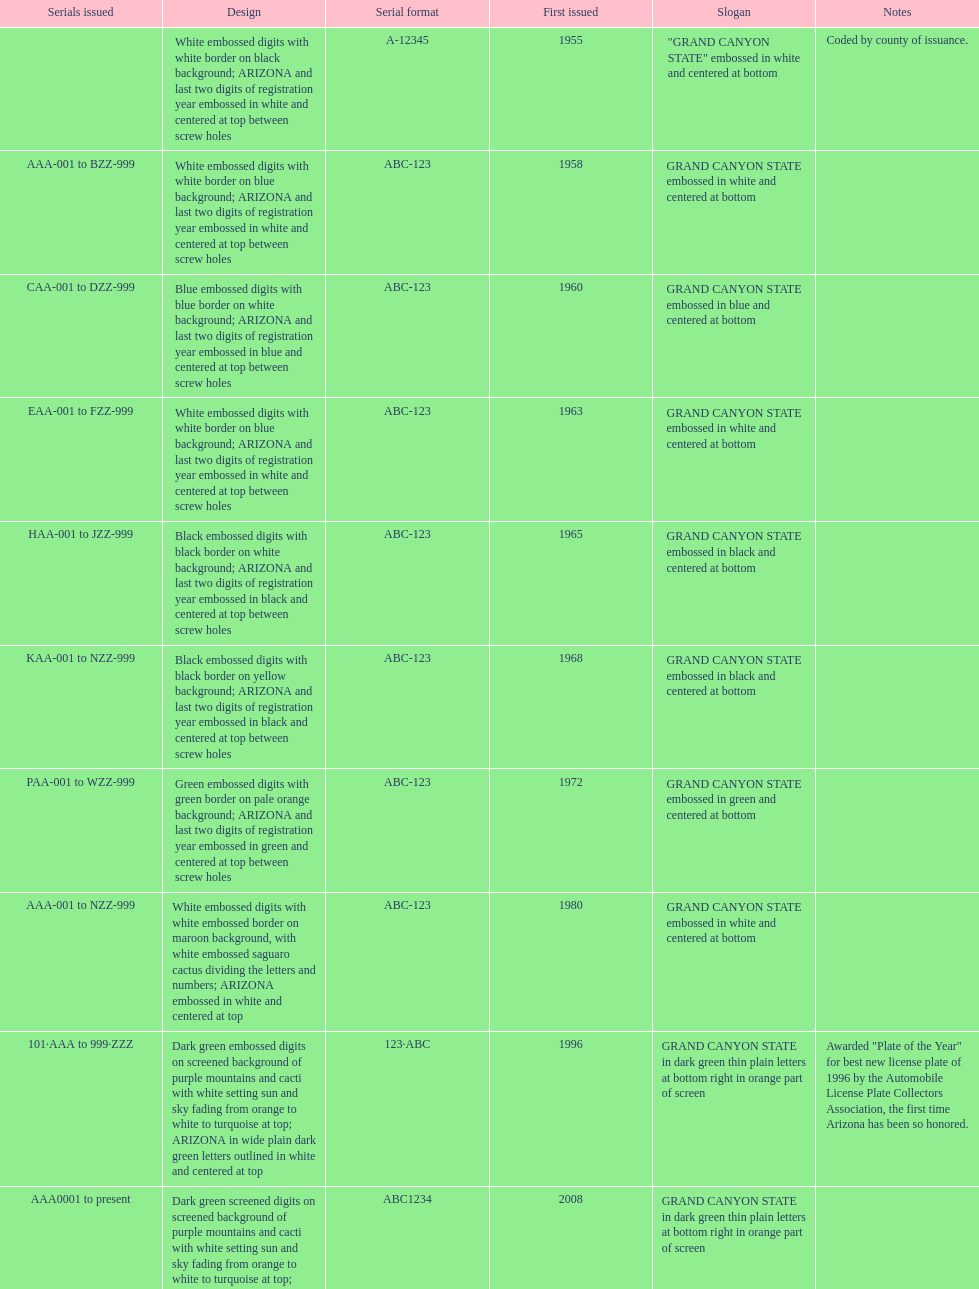Would you mind parsing the complete table? {'header': ['Serials issued', 'Design', 'Serial format', 'First issued', 'Slogan', 'Notes'], 'rows': [['', 'White embossed digits with white border on black background; ARIZONA and last two digits of registration year embossed in white and centered at top between screw holes', 'A-12345', '1955', '"GRAND CANYON STATE" embossed in white and centered at bottom', 'Coded by county of issuance.'], ['AAA-001 to BZZ-999', 'White embossed digits with white border on blue background; ARIZONA and last two digits of registration year embossed in white and centered at top between screw holes', 'ABC-123', '1958', 'GRAND CANYON STATE embossed in white and centered at bottom', ''], ['CAA-001 to DZZ-999', 'Blue embossed digits with blue border on white background; ARIZONA and last two digits of registration year embossed in blue and centered at top between screw holes', 'ABC-123', '1960', 'GRAND CANYON STATE embossed in blue and centered at bottom', ''], ['EAA-001 to FZZ-999', 'White embossed digits with white border on blue background; ARIZONA and last two digits of registration year embossed in white and centered at top between screw holes', 'ABC-123', '1963', 'GRAND CANYON STATE embossed in white and centered at bottom', ''], ['HAA-001 to JZZ-999', 'Black embossed digits with black border on white background; ARIZONA and last two digits of registration year embossed in black and centered at top between screw holes', 'ABC-123', '1965', 'GRAND CANYON STATE embossed in black and centered at bottom', ''], ['KAA-001 to NZZ-999', 'Black embossed digits with black border on yellow background; ARIZONA and last two digits of registration year embossed in black and centered at top between screw holes', 'ABC-123', '1968', 'GRAND CANYON STATE embossed in black and centered at bottom', ''], ['PAA-001 to WZZ-999', 'Green embossed digits with green border on pale orange background; ARIZONA and last two digits of registration year embossed in green and centered at top between screw holes', 'ABC-123', '1972', 'GRAND CANYON STATE embossed in green and centered at bottom', ''], ['AAA-001 to NZZ-999', 'White embossed digits with white embossed border on maroon background, with white embossed saguaro cactus dividing the letters and numbers; ARIZONA embossed in white and centered at top', 'ABC-123', '1980', 'GRAND CANYON STATE embossed in white and centered at bottom', ''], ['101·AAA to 999·ZZZ', 'Dark green embossed digits on screened background of purple mountains and cacti with white setting sun and sky fading from orange to white to turquoise at top; ARIZONA in wide plain dark green letters outlined in white and centered at top', '123·ABC', '1996', 'GRAND CANYON STATE in dark green thin plain letters at bottom right in orange part of screen', 'Awarded "Plate of the Year" for best new license plate of 1996 by the Automobile License Plate Collectors Association, the first time Arizona has been so honored.'], ['AAA0001 to present', 'Dark green screened digits on screened background of purple mountains and cacti with white setting sun and sky fading from orange to white to turquoise at top; ARIZONA in wide plain dark green letters outlined in white and centered at top; security stripe through center of plate', 'ABC1234', '2008', 'GRAND CANYON STATE in dark green thin plain letters at bottom right in orange part of screen', '']]} What is the average serial format of the arizona license plates? ABC-123. 